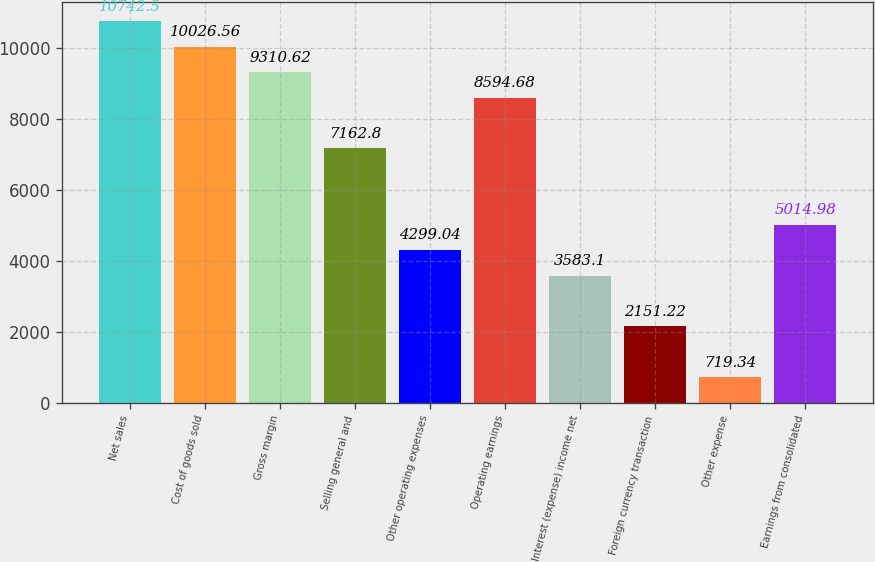Convert chart to OTSL. <chart><loc_0><loc_0><loc_500><loc_500><bar_chart><fcel>Net sales<fcel>Cost of goods sold<fcel>Gross margin<fcel>Selling general and<fcel>Other operating expenses<fcel>Operating earnings<fcel>Interest (expense) income net<fcel>Foreign currency transaction<fcel>Other expense<fcel>Earnings from consolidated<nl><fcel>10742.5<fcel>10026.6<fcel>9310.62<fcel>7162.8<fcel>4299.04<fcel>8594.68<fcel>3583.1<fcel>2151.22<fcel>719.34<fcel>5014.98<nl></chart> 